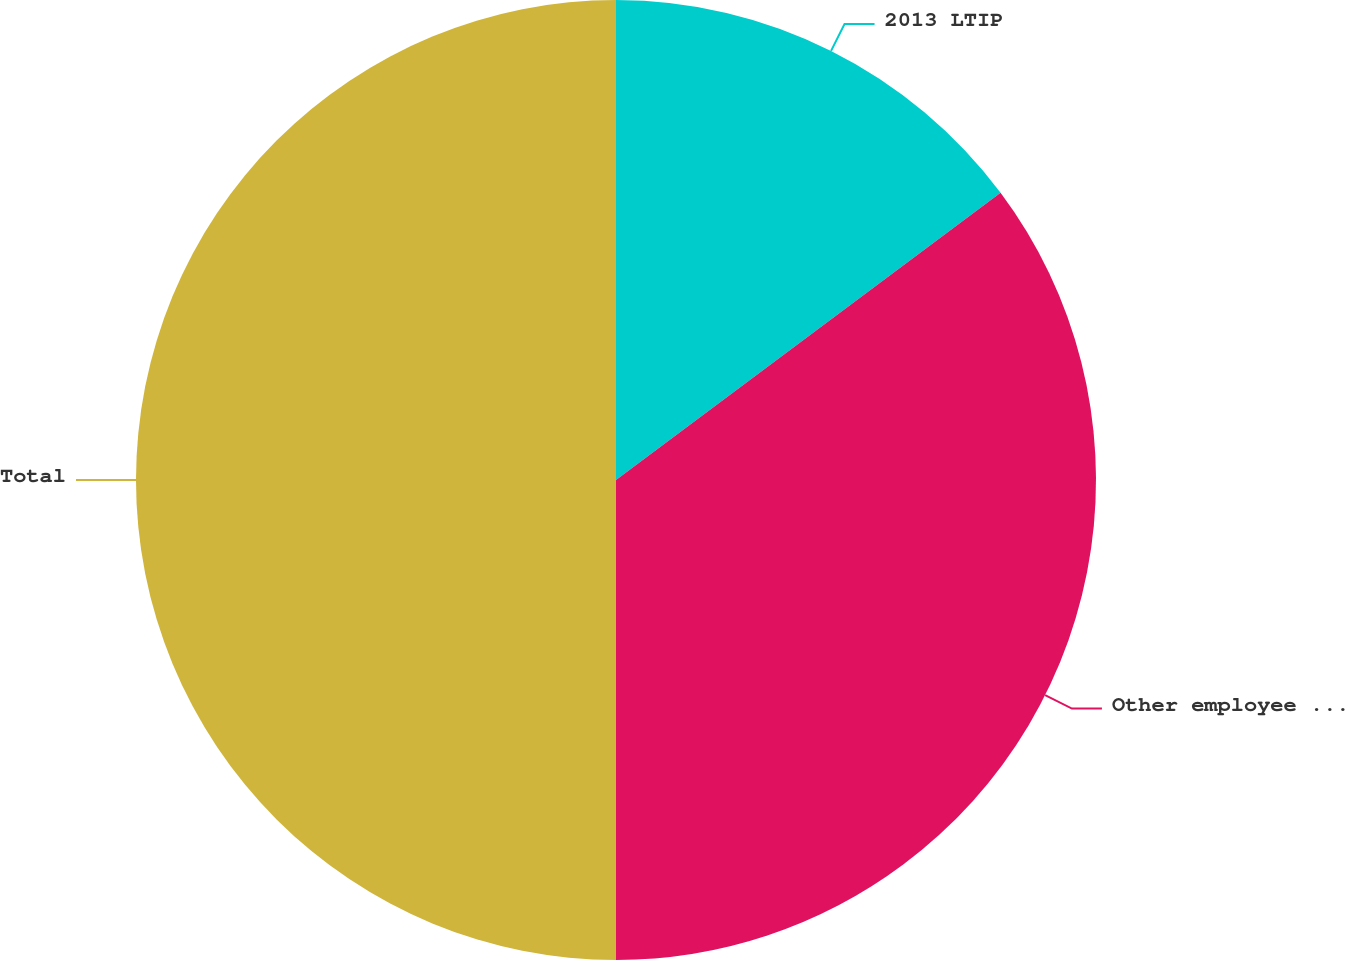<chart> <loc_0><loc_0><loc_500><loc_500><pie_chart><fcel>2013 LTIP<fcel>Other employee performance<fcel>Total<nl><fcel>14.79%<fcel>35.21%<fcel>50.0%<nl></chart> 